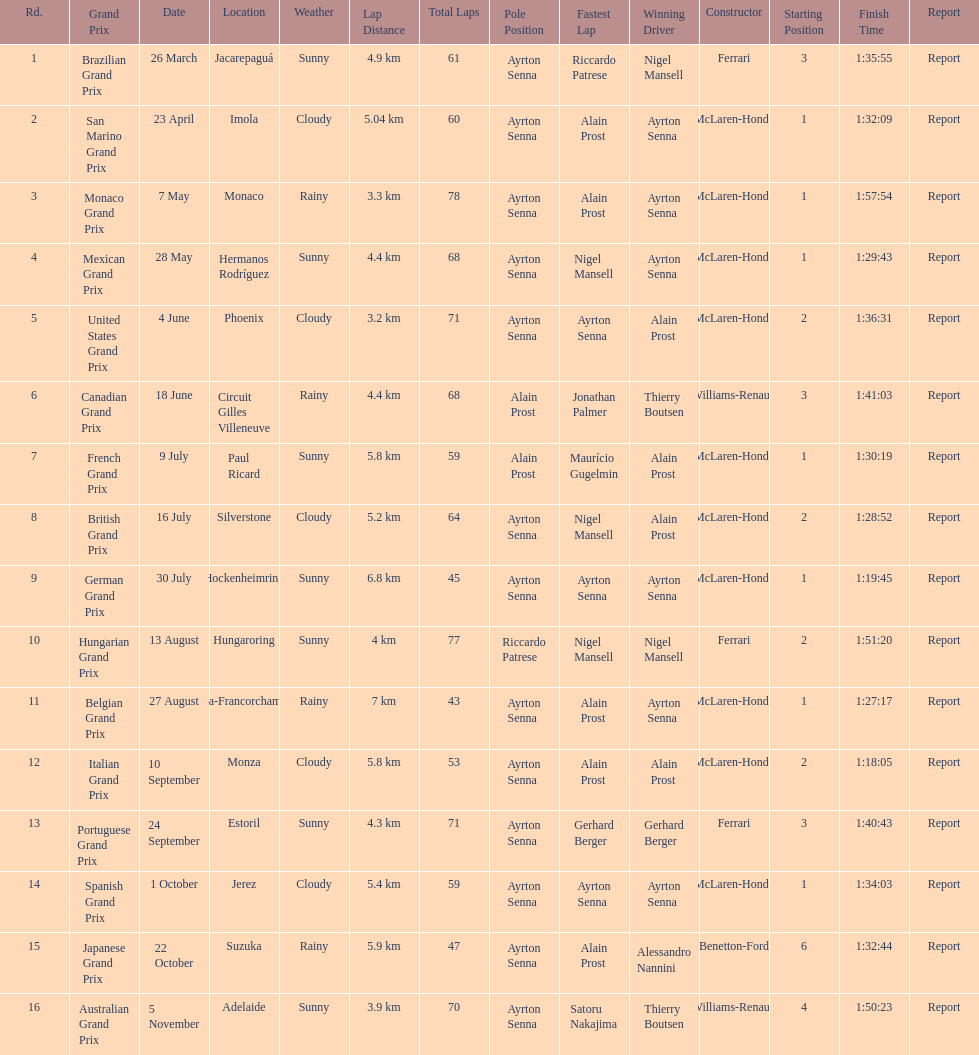What was the only grand prix to be won by benneton-ford? Japanese Grand Prix. 